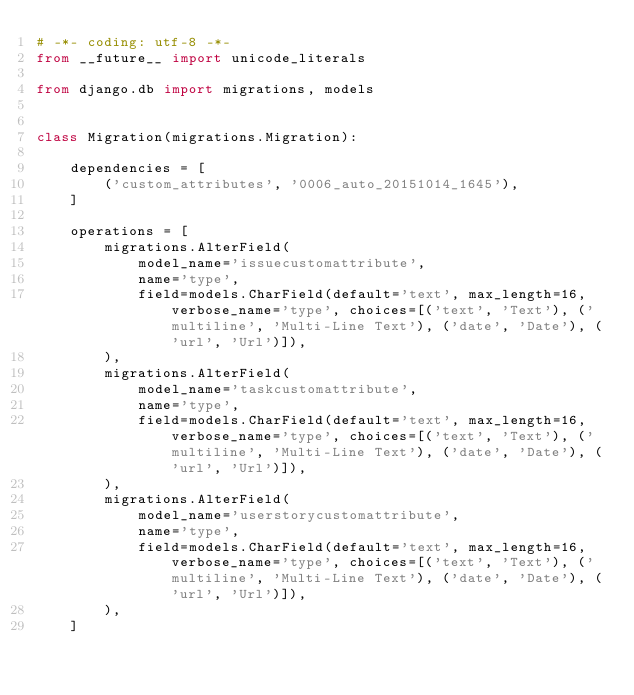<code> <loc_0><loc_0><loc_500><loc_500><_Python_># -*- coding: utf-8 -*-
from __future__ import unicode_literals

from django.db import migrations, models


class Migration(migrations.Migration):

    dependencies = [
        ('custom_attributes', '0006_auto_20151014_1645'),
    ]

    operations = [
        migrations.AlterField(
            model_name='issuecustomattribute',
            name='type',
            field=models.CharField(default='text', max_length=16, verbose_name='type', choices=[('text', 'Text'), ('multiline', 'Multi-Line Text'), ('date', 'Date'), ('url', 'Url')]),
        ),
        migrations.AlterField(
            model_name='taskcustomattribute',
            name='type',
            field=models.CharField(default='text', max_length=16, verbose_name='type', choices=[('text', 'Text'), ('multiline', 'Multi-Line Text'), ('date', 'Date'), ('url', 'Url')]),
        ),
        migrations.AlterField(
            model_name='userstorycustomattribute',
            name='type',
            field=models.CharField(default='text', max_length=16, verbose_name='type', choices=[('text', 'Text'), ('multiline', 'Multi-Line Text'), ('date', 'Date'), ('url', 'Url')]),
        ),
    ]
</code> 